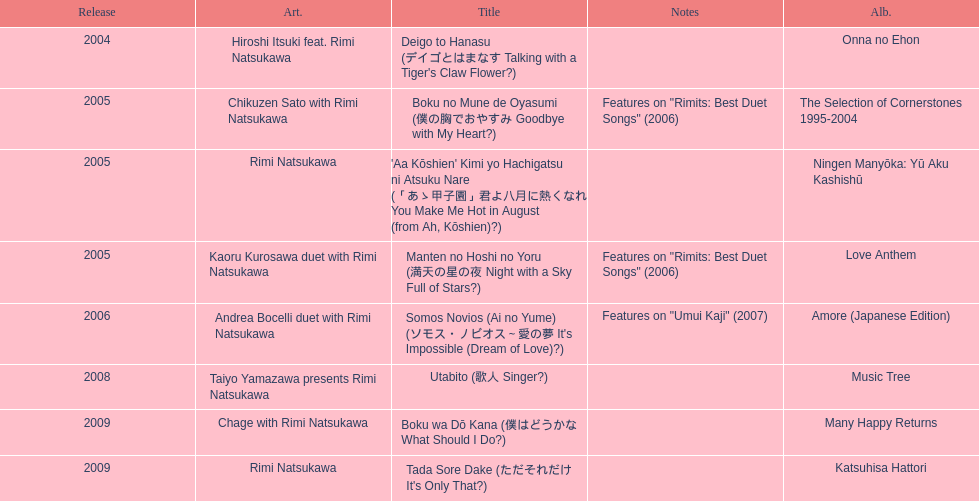What is the number of albums released with the artist rimi natsukawa? 8. 